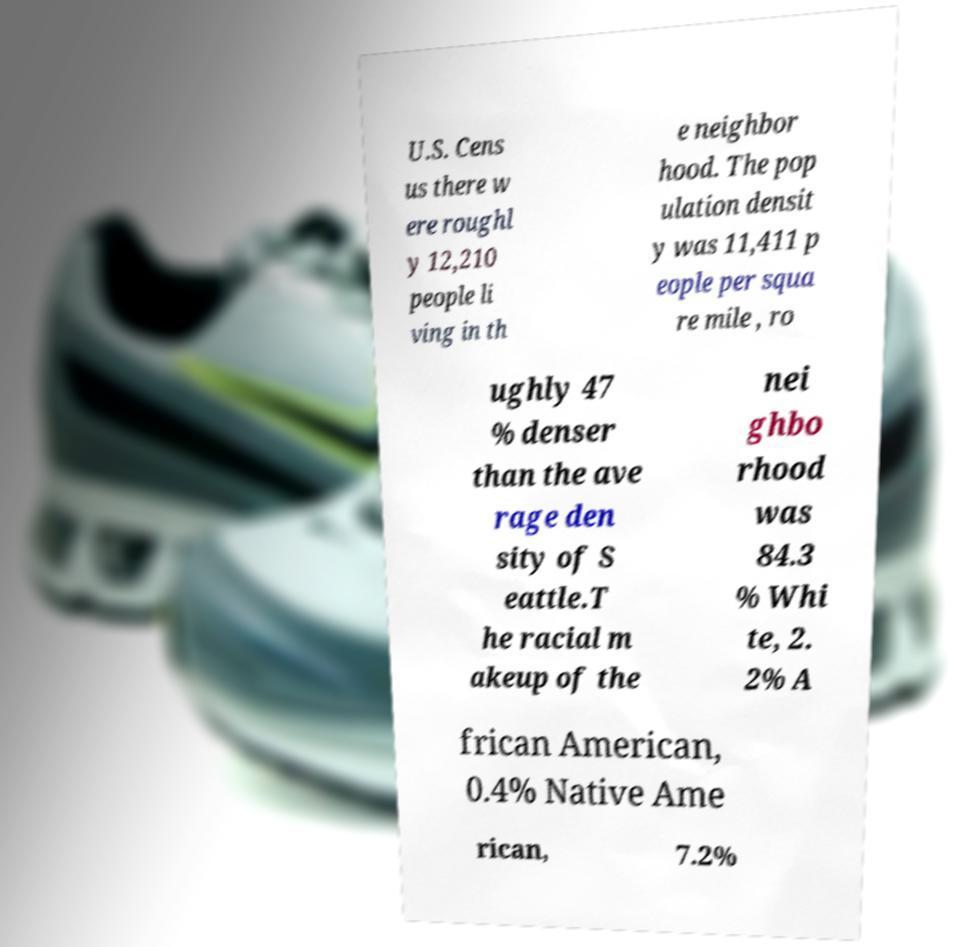For documentation purposes, I need the text within this image transcribed. Could you provide that? U.S. Cens us there w ere roughl y 12,210 people li ving in th e neighbor hood. The pop ulation densit y was 11,411 p eople per squa re mile , ro ughly 47 % denser than the ave rage den sity of S eattle.T he racial m akeup of the nei ghbo rhood was 84.3 % Whi te, 2. 2% A frican American, 0.4% Native Ame rican, 7.2% 